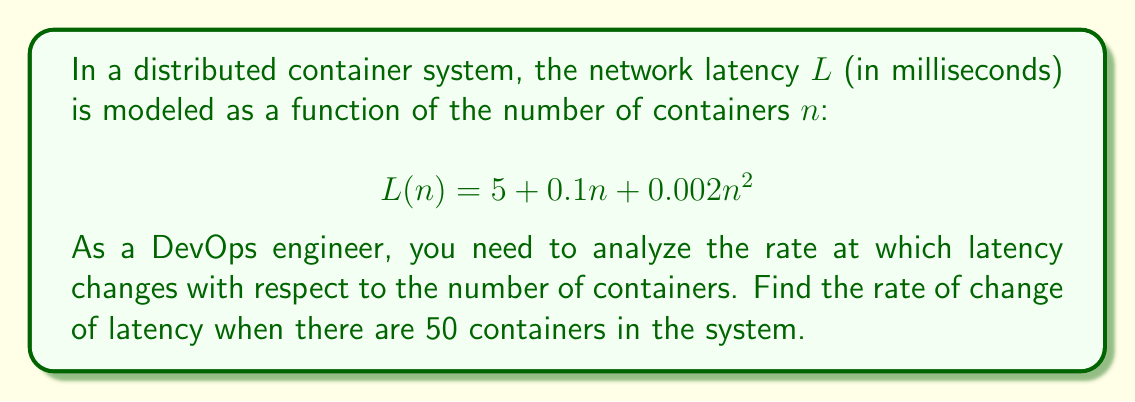Can you solve this math problem? To find the rate of change of latency with respect to the number of containers, we need to calculate the derivative of the latency function $L(n)$.

Step 1: Identify the function
$$L(n) = 5 + 0.1n + 0.002n^2$$

Step 2: Calculate the derivative $L'(n)$
Using the power rule and constant rule of differentiation:
$$L'(n) = 0 + 0.1 + 0.002 \cdot 2n$$
$$L'(n) = 0.1 + 0.004n$$

Step 3: Evaluate $L'(n)$ at $n = 50$
$$L'(50) = 0.1 + 0.004 \cdot 50$$
$$L'(50) = 0.1 + 0.2$$
$$L'(50) = 0.3$$

This means that when there are 50 containers, the latency is increasing at a rate of 0.3 milliseconds per additional container.
Answer: $0.3$ ms/container 